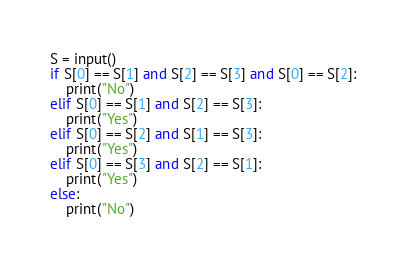Convert code to text. <code><loc_0><loc_0><loc_500><loc_500><_Python_>S = input()
if S[0] == S[1] and S[2] == S[3] and S[0] == S[2]:
    print("No")
elif S[0] == S[1] and S[2] == S[3]:
    print("Yes")
elif S[0] == S[2] and S[1] == S[3]:
    print("Yes")
elif S[0] == S[3] and S[2] == S[1]:
    print("Yes")
else:
    print("No")</code> 